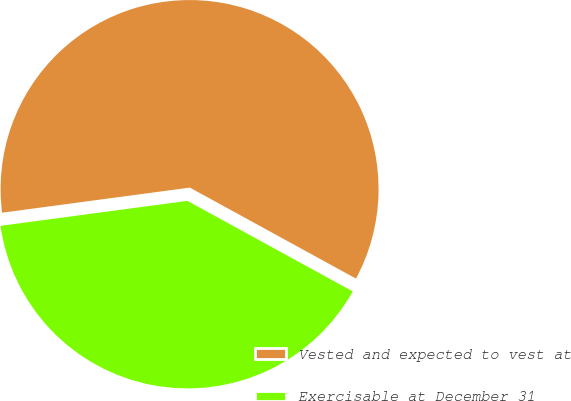Convert chart. <chart><loc_0><loc_0><loc_500><loc_500><pie_chart><fcel>Vested and expected to vest at<fcel>Exercisable at December 31<nl><fcel>60.09%<fcel>39.91%<nl></chart> 